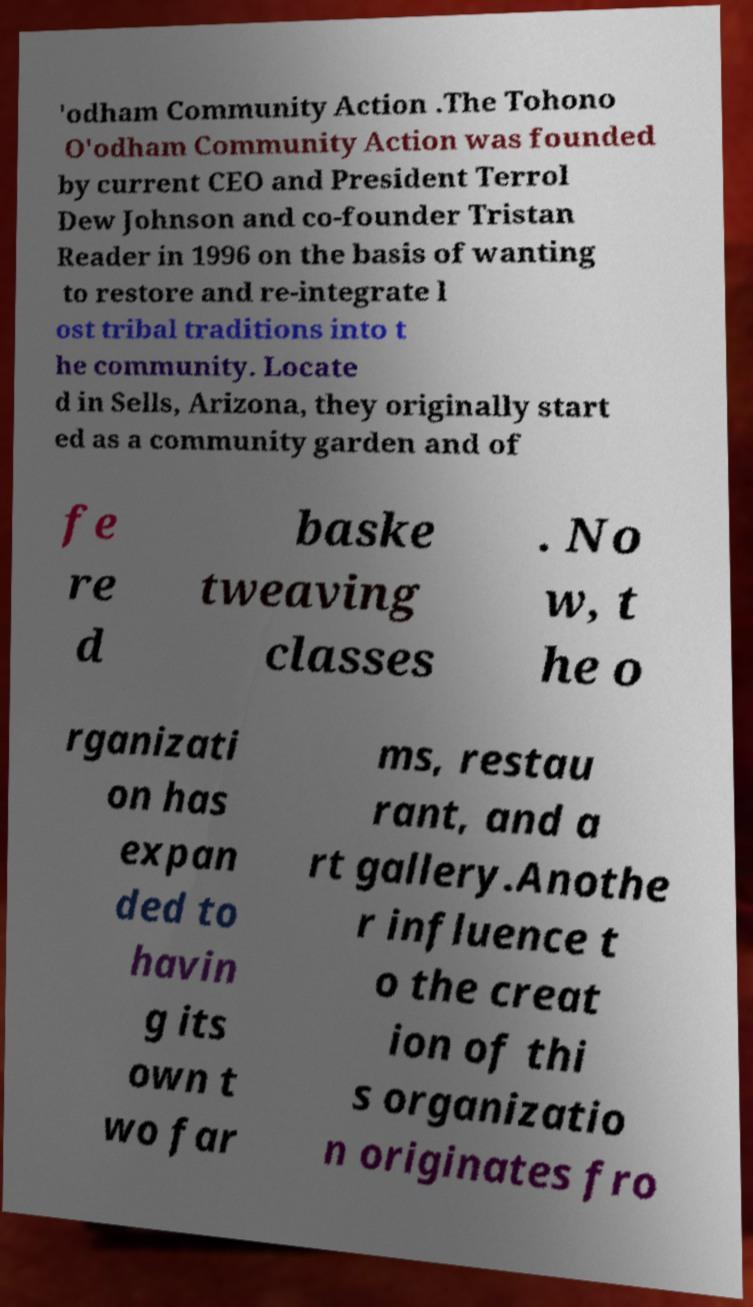Can you read and provide the text displayed in the image?This photo seems to have some interesting text. Can you extract and type it out for me? 'odham Community Action .The Tohono O'odham Community Action was founded by current CEO and President Terrol Dew Johnson and co-founder Tristan Reader in 1996 on the basis of wanting to restore and re-integrate l ost tribal traditions into t he community. Locate d in Sells, Arizona, they originally start ed as a community garden and of fe re d baske tweaving classes . No w, t he o rganizati on has expan ded to havin g its own t wo far ms, restau rant, and a rt gallery.Anothe r influence t o the creat ion of thi s organizatio n originates fro 